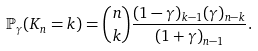Convert formula to latex. <formula><loc_0><loc_0><loc_500><loc_500>\mathbb { P } _ { \gamma } ( K _ { n } = k ) = { n \choose k } \frac { ( 1 - \gamma ) _ { k - 1 } ( \gamma ) _ { n - k } } { ( 1 + \gamma ) _ { n - 1 } } .</formula> 